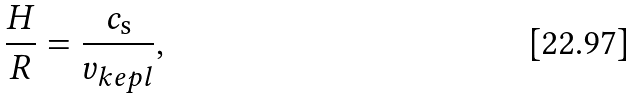Convert formula to latex. <formula><loc_0><loc_0><loc_500><loc_500>\frac { H } { R } = \frac { c _ { \mathrm s } } { v _ { k e p l } } ,</formula> 